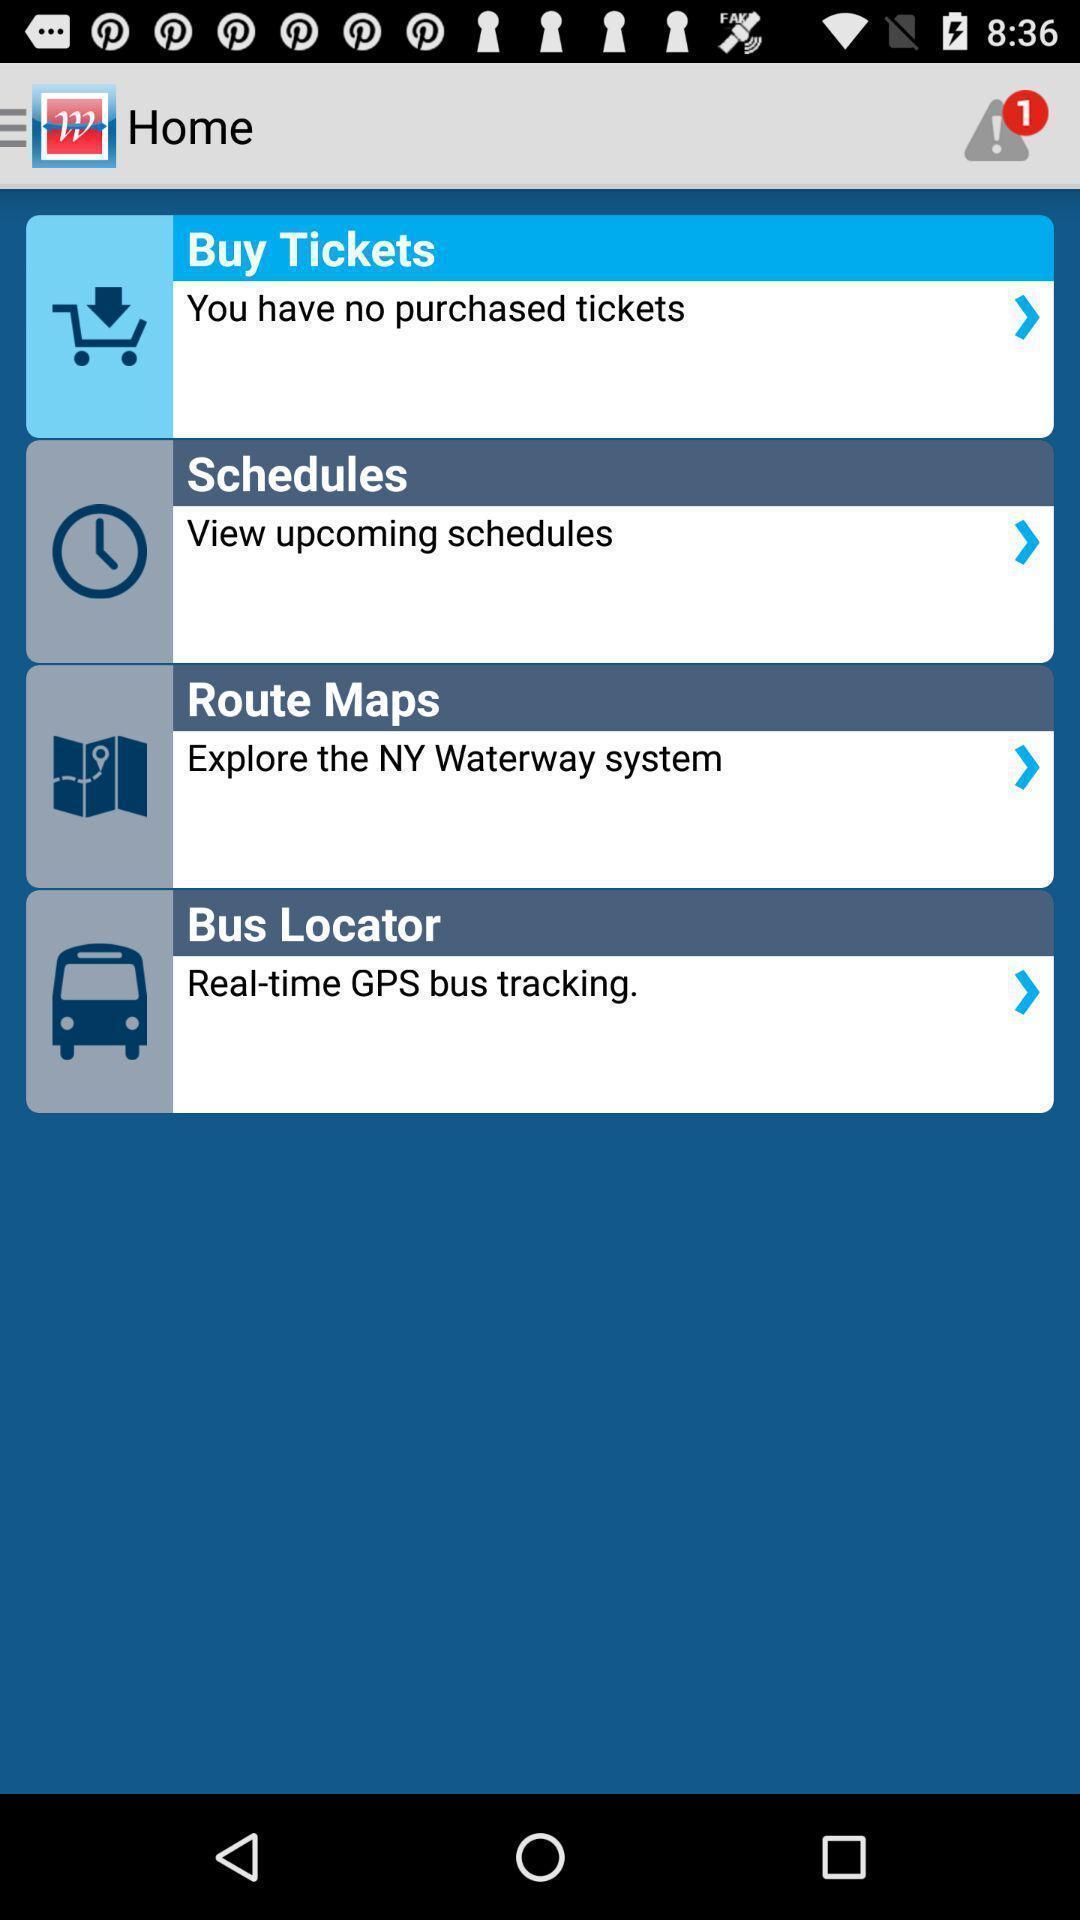Explain what's happening in this screen capture. Screen displaying home page. 